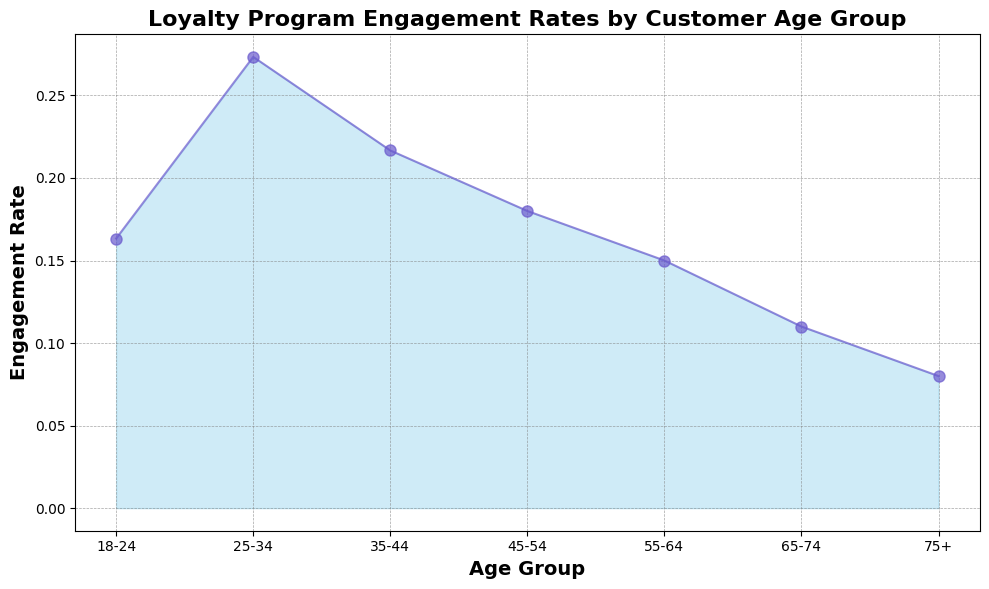What age group has the highest loyalty program engagement rate? The highest point of the graph is observed by looking at the peak of the area chart. Here, the peak is around the age group 25-34.
Answer: 25-34 Which age group has a lower engagement rate, 18-24 or 45-54? By comparing the heights of the area for these age groups, we see that the line for 45-54 is lower than that of 18-24.
Answer: 45-54 What is the difference in engagement rate between the 25-34 and 75+ age groups? Identify the engagement rates for the 25-34 (0.27) and 75+ (0.08) age groups and subtract the smaller from the larger: 0.27 - 0.08 = 0.19.
Answer: 0.19 Is the engagement rate for the 35-44 age group closer to that of 25-34 or 45-54? Comparing the heights, the engagement rate for 35-44 (0.22) is closer to 25-34 (0.27) than 45-54 (0.17). The absolute differences are 0.05 (35-44 to 25-34) and 0.05 (35-44 to 45-54).
Answer: 25-34 What is the average engagement rate across all age groups? Calculate the average by summing the mean engagement rates for each age group (0.15 + 0.27 + 0.22 + 0.18 + 0.15 + 0.11 + 0.08 = 1.16) and dividing by the number of age groups (1.16 / 7).
Answer: 0.17 Which age group sees a decline in engagement rate when compared to the preceding age group? Look at where the engagement rates decrease from one age group to the next. From age group 25-34 (0.27) to 35-44 (0.22), and from 45-54 (0.18) to 55-64 (0.15), these points show a decline.
Answer: 35-44, 55-64 What is the visual difference between the engagement rate of the 25-34 and the 65-74 age groups? The 25-34 age group has a much taller and pronounced peak compared to the relatively lower and flatter appearance for the 65-74 age group.
Answer: Taller and pronounced Is the engagement rate trend consistent as age increases? Observing the shape of the area chart, the general trend is a downward slope indicating that engagement tends to decrease as age increases.
Answer: Decreasing trend How much higher is the engagement rate for the 25-34 age group compared to the 55-64 age group? Take the engagement rates for 25-34 (0.27) and 55-64 (0.15) and find the difference: 0.27 - 0.15 = 0.12.
Answer: 0.12 